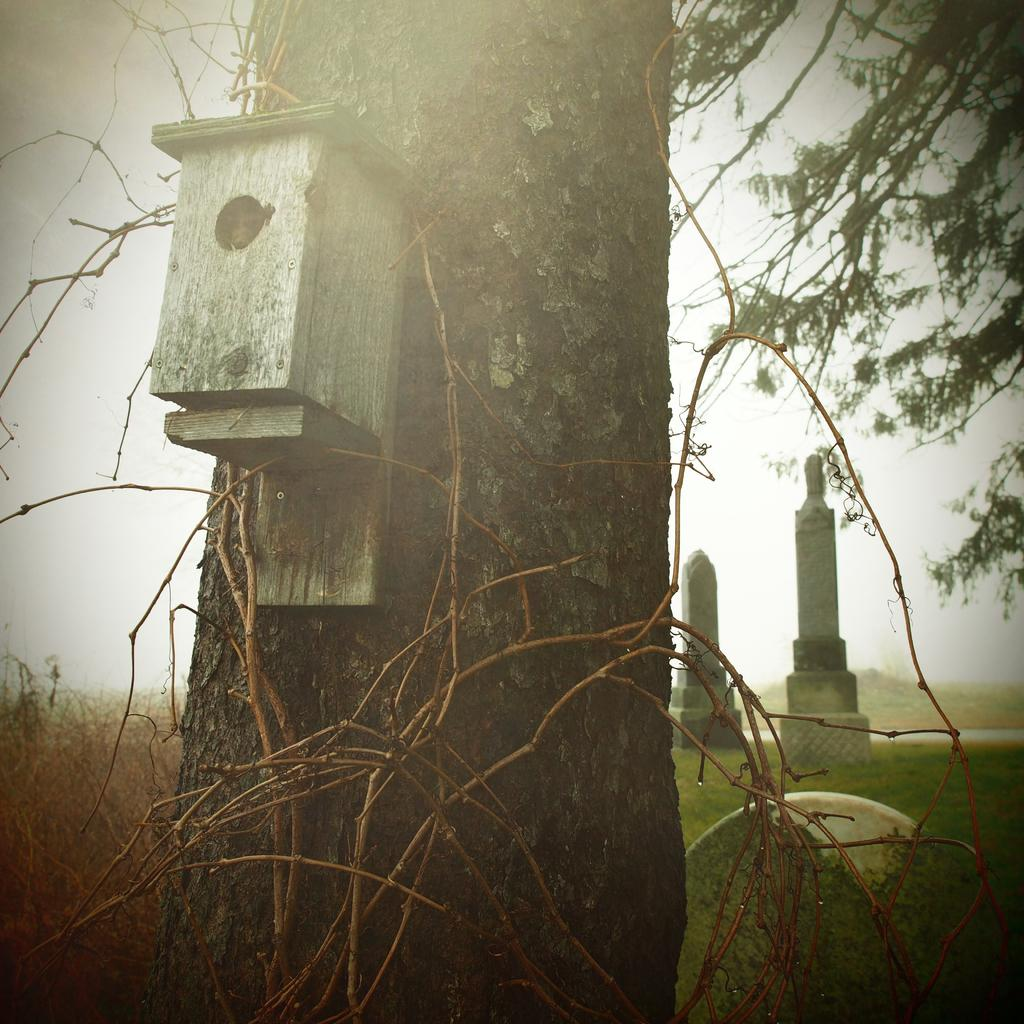What is attached to the trunk of the tree in the image? There is a box attached to the trunk of a tree in the image. What type of architectural elements can be seen in the image? There are stone pillars in the image. What type of vegetation is present in the image? There are plants in the image. Where is the toy located in the image? There is no toy present in the image. What color is the station in the image? There is no station present in the image. 